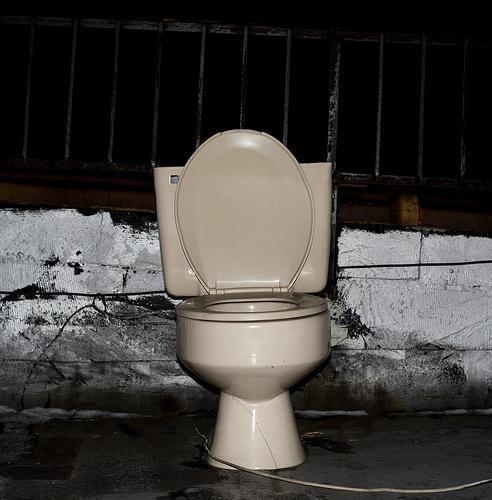How many toilets are there?
Give a very brief answer. 1. 